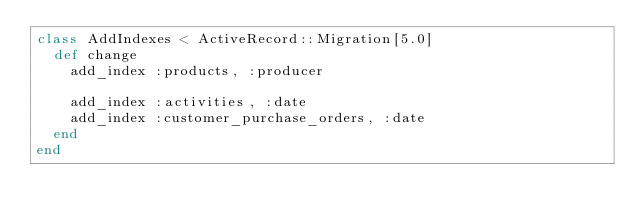Convert code to text. <code><loc_0><loc_0><loc_500><loc_500><_Ruby_>class AddIndexes < ActiveRecord::Migration[5.0]
  def change
    add_index :products, :producer

    add_index :activities, :date
    add_index :customer_purchase_orders, :date
  end
end
</code> 